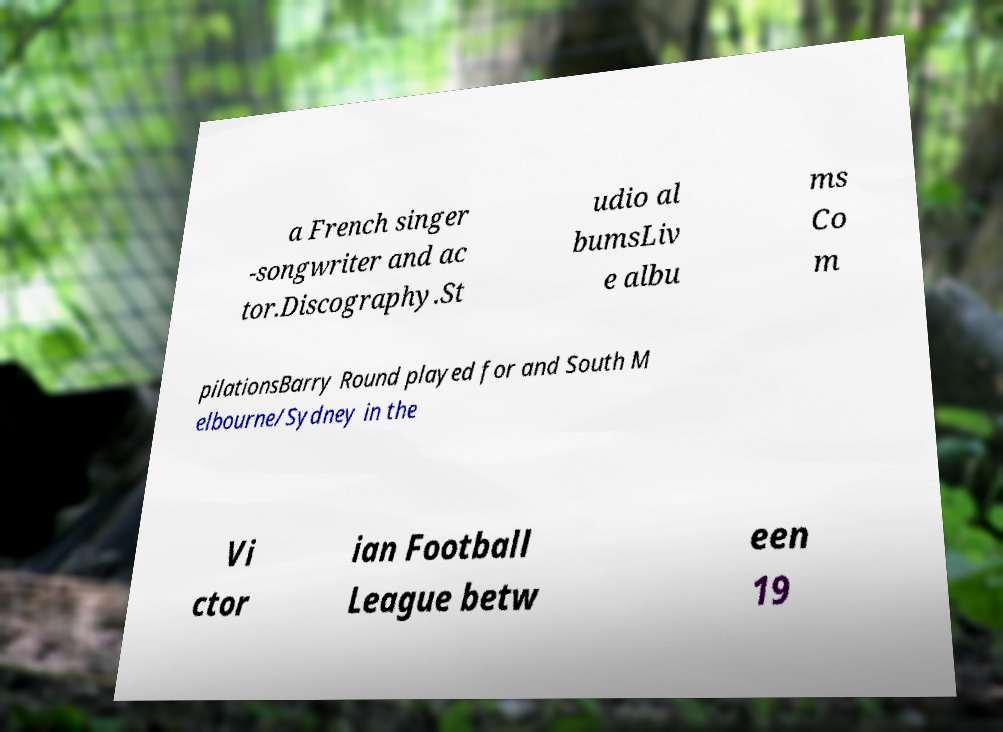Can you read and provide the text displayed in the image?This photo seems to have some interesting text. Can you extract and type it out for me? a French singer -songwriter and ac tor.Discography.St udio al bumsLiv e albu ms Co m pilationsBarry Round played for and South M elbourne/Sydney in the Vi ctor ian Football League betw een 19 